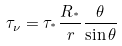Convert formula to latex. <formula><loc_0><loc_0><loc_500><loc_500>\tau _ { \nu } = \tau _ { ^ { * } } \frac { R _ { ^ { * } } } { r } \frac { \theta } { \sin \theta }</formula> 